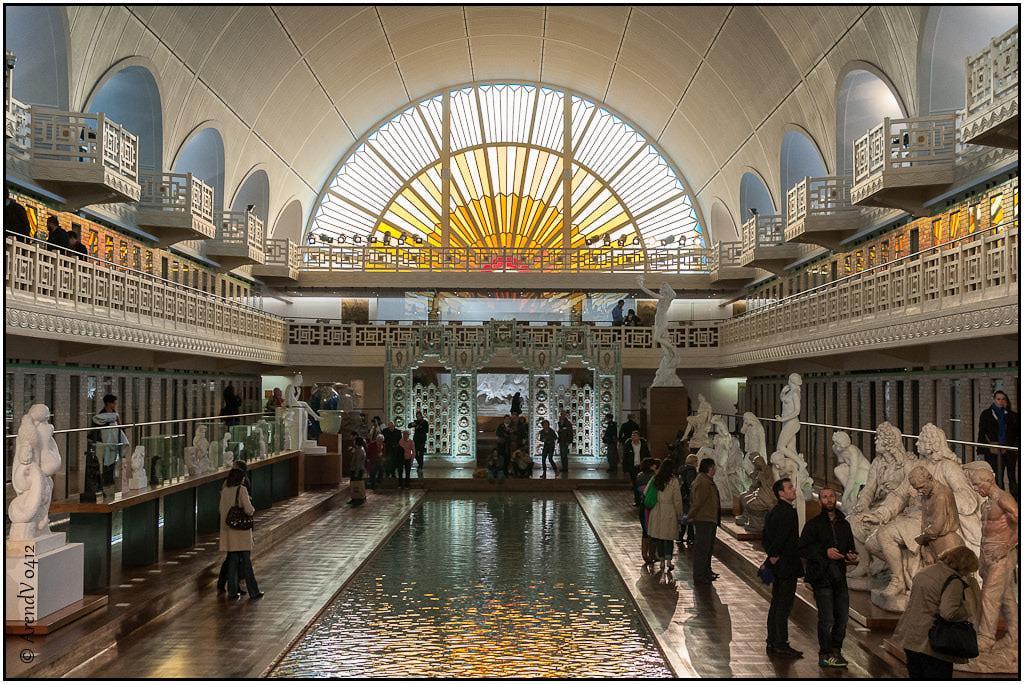Please provide a concise description of this image. In the pictures I can see the statues on the left side and the right side as well. I can see a few people standing on the floor and they are looking at the statues. I can see the water pool at the bottom of the picture. I can see the arch design construction on the left side and the right side as well. In the background, I can see the design glass window. I can see a few people sitting on the side of the water pool. 